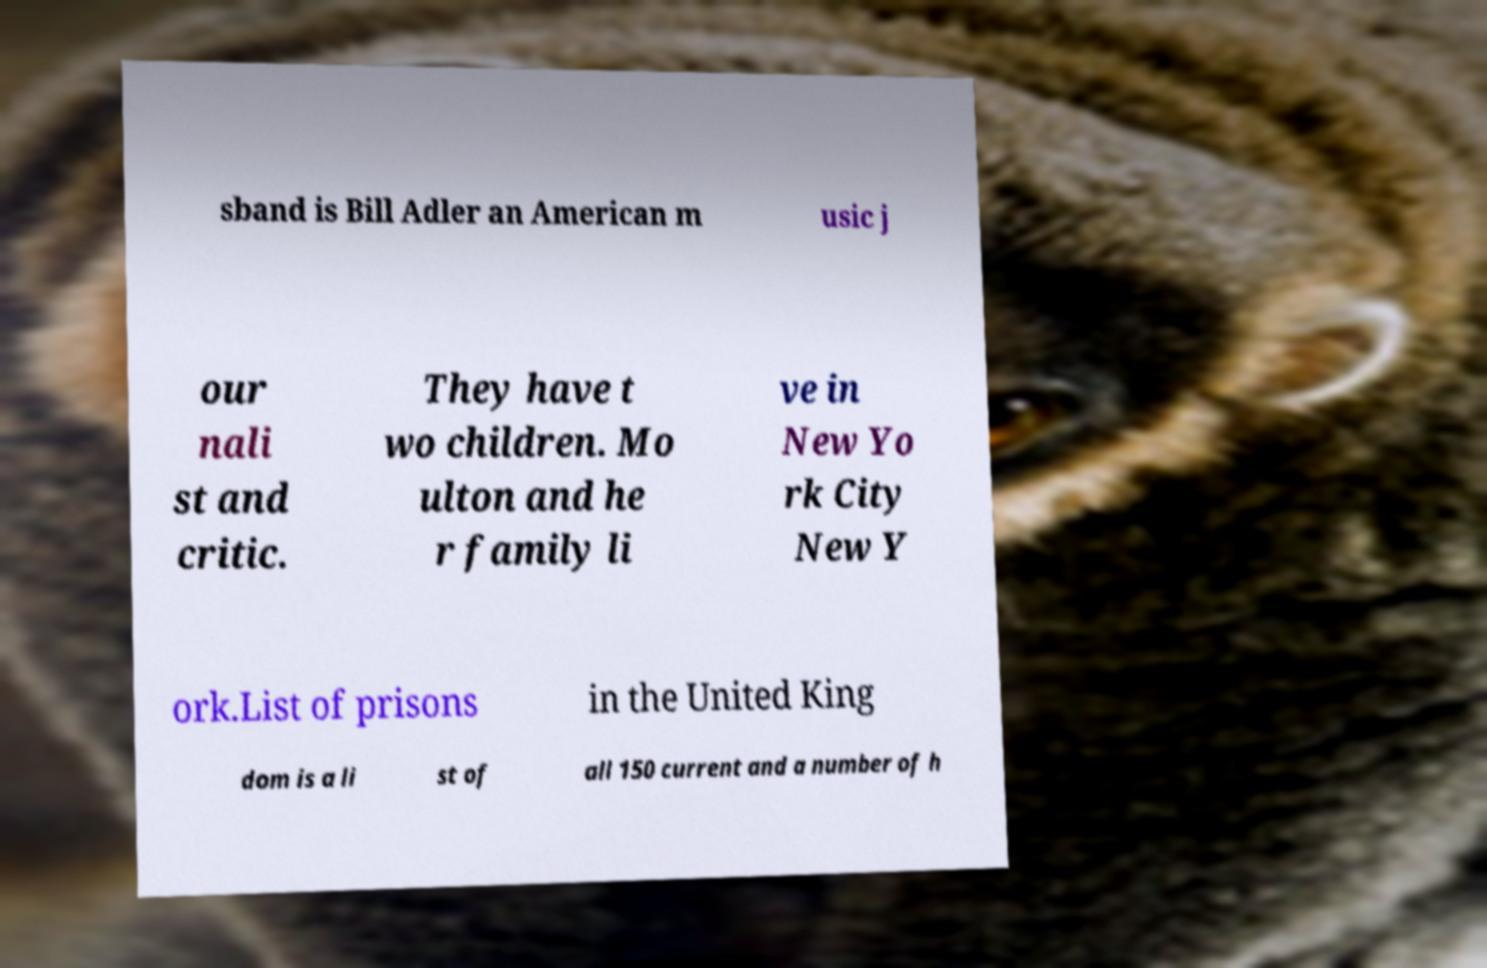Could you assist in decoding the text presented in this image and type it out clearly? sband is Bill Adler an American m usic j our nali st and critic. They have t wo children. Mo ulton and he r family li ve in New Yo rk City New Y ork.List of prisons in the United King dom is a li st of all 150 current and a number of h 